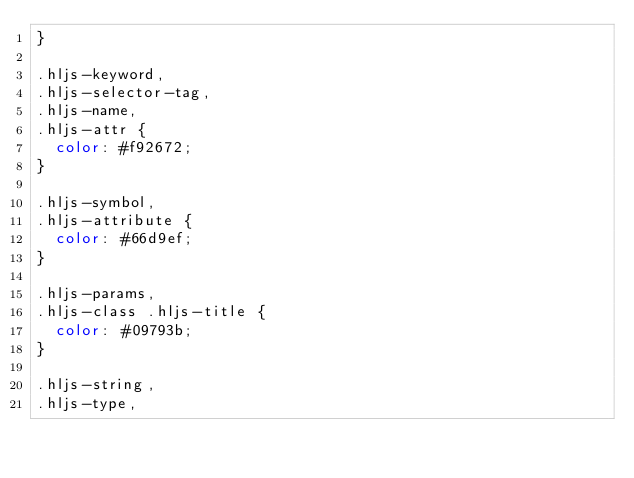<code> <loc_0><loc_0><loc_500><loc_500><_CSS_>}

.hljs-keyword,
.hljs-selector-tag,
.hljs-name,
.hljs-attr {
  color: #f92672;
}

.hljs-symbol,
.hljs-attribute {
  color: #66d9ef;
}

.hljs-params,
.hljs-class .hljs-title {
  color: #09793b;
}

.hljs-string,
.hljs-type,</code> 